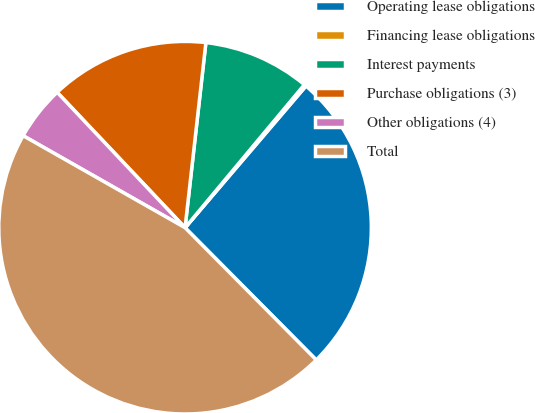<chart> <loc_0><loc_0><loc_500><loc_500><pie_chart><fcel>Operating lease obligations<fcel>Financing lease obligations<fcel>Interest payments<fcel>Purchase obligations (3)<fcel>Other obligations (4)<fcel>Total<nl><fcel>26.32%<fcel>0.18%<fcel>9.28%<fcel>13.83%<fcel>4.73%<fcel>45.66%<nl></chart> 